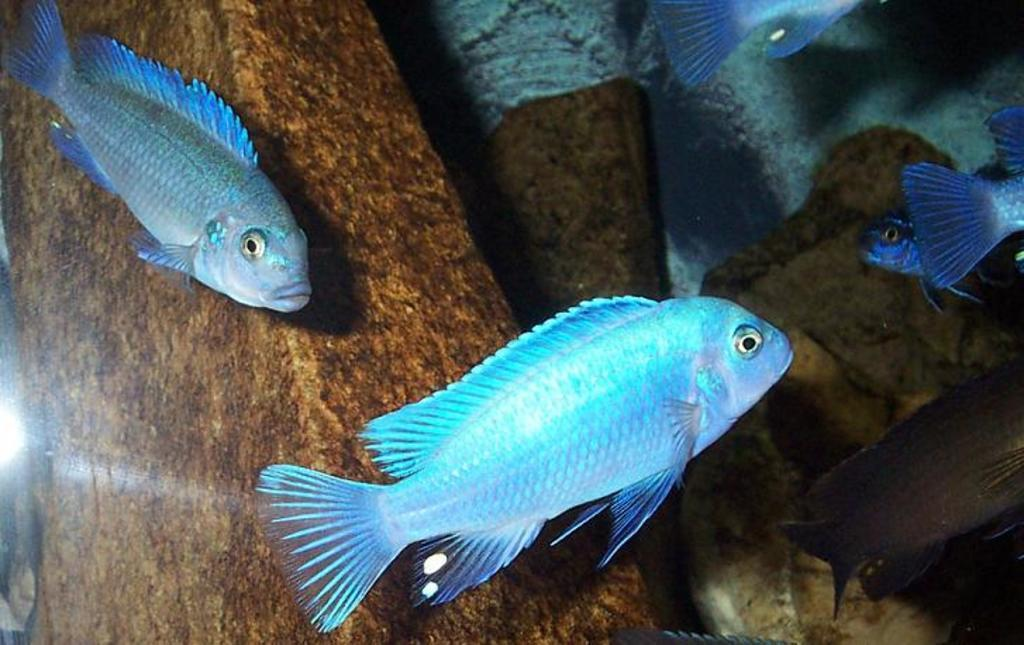What type of animals can be seen in the foreground of the image? There are fish in the foreground of the image. What is the primary element in which the fish are situated? There is water in the image, and the fish are situated in it. What can be seen in the water besides the fish? There are objects visible in the water. What type of ground is visible in the image? There is white sand visible in the image. What language is spoken by the fish in the image? There is no indication in the image that the fish are speaking any language. 